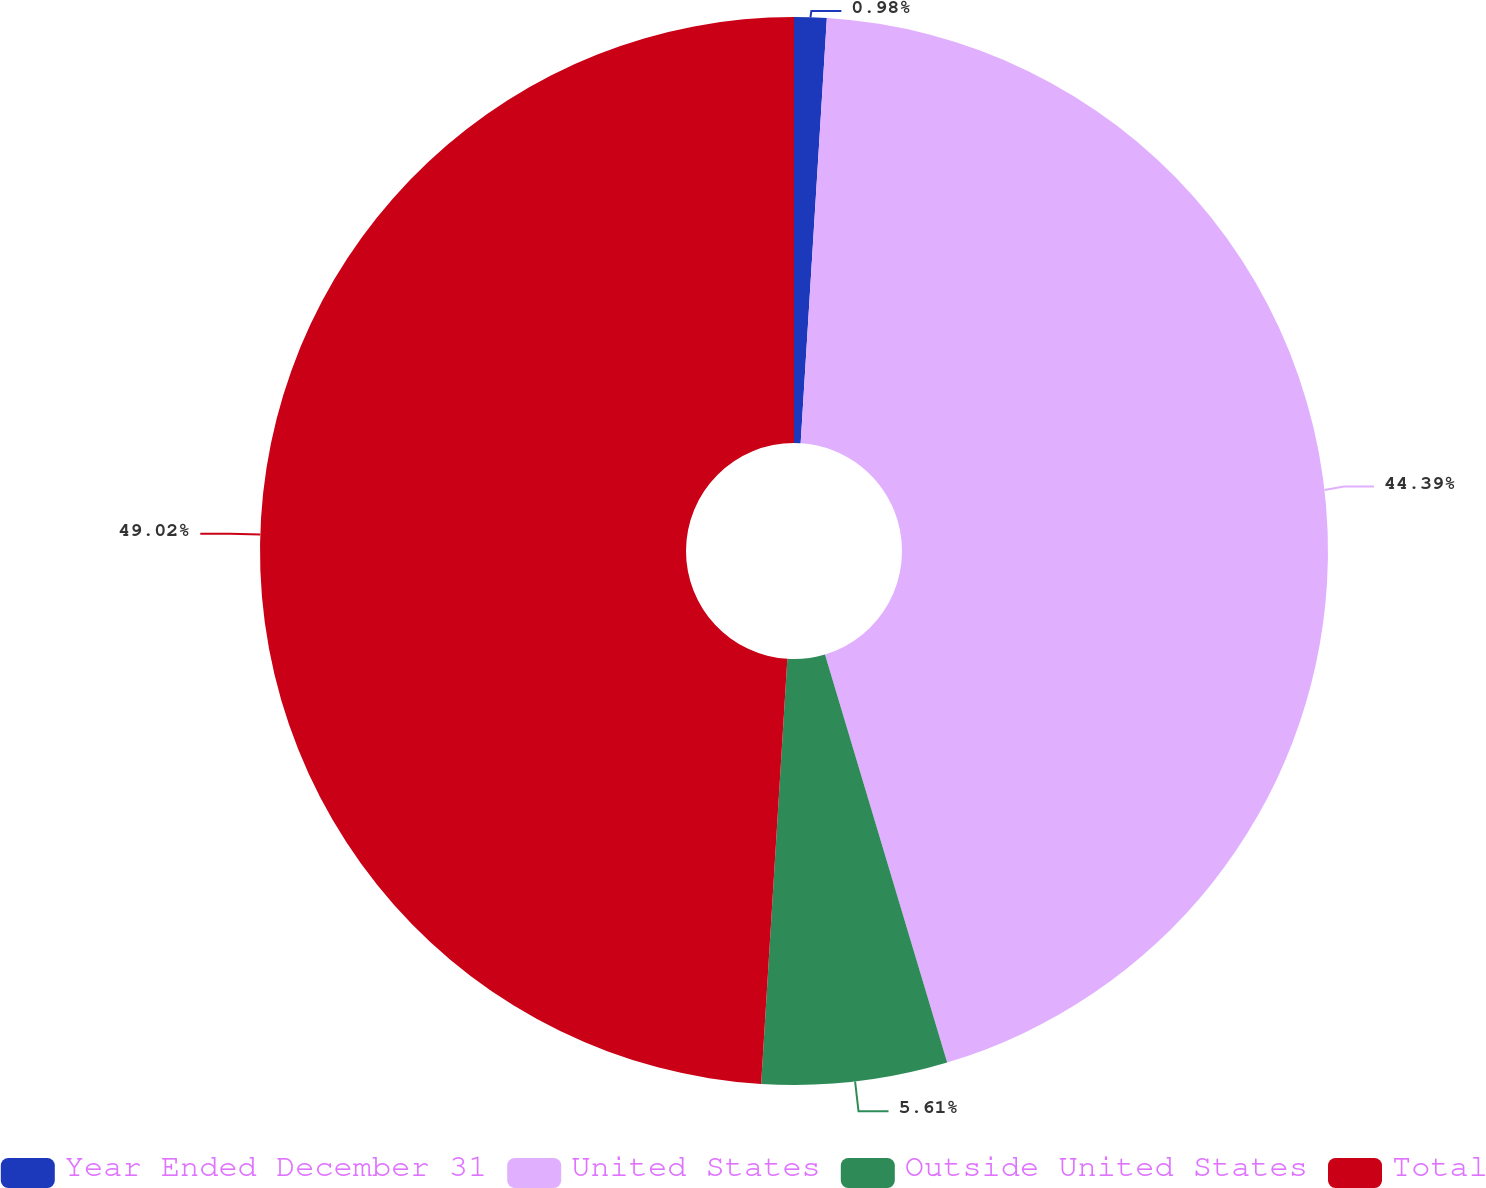Convert chart. <chart><loc_0><loc_0><loc_500><loc_500><pie_chart><fcel>Year Ended December 31<fcel>United States<fcel>Outside United States<fcel>Total<nl><fcel>0.98%<fcel>44.39%<fcel>5.61%<fcel>49.02%<nl></chart> 